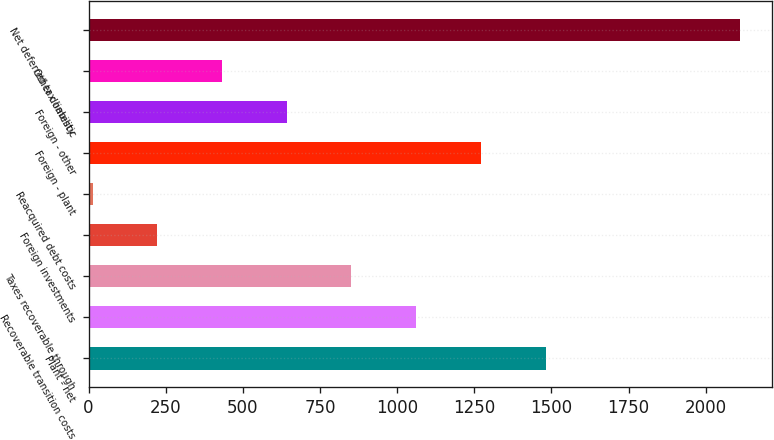Convert chart. <chart><loc_0><loc_0><loc_500><loc_500><bar_chart><fcel>Plant - net<fcel>Recoverable transition costs<fcel>Taxes recoverable through<fcel>Foreign investments<fcel>Reacquired debt costs<fcel>Foreign - plant<fcel>Foreign - other<fcel>Other domestic<fcel>Net deferred tax liability<nl><fcel>1480.9<fcel>1061.5<fcel>851.8<fcel>222.7<fcel>13<fcel>1271.2<fcel>642.1<fcel>432.4<fcel>2110<nl></chart> 